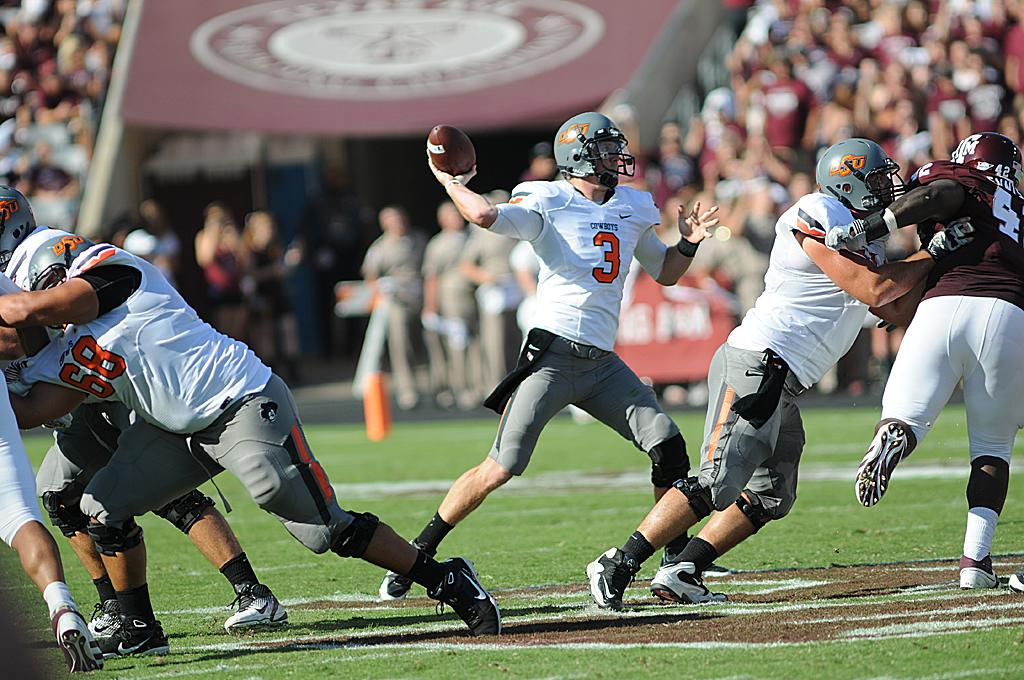What activity are the people in the image engaged in? The people in the image are playing a game. Where is the game being played? The game is being played on the grass. What object is being used in the game? A person is holding a ball in the image. Can you describe the background of the image? The background of the image is blurry. Are there any other people visible in the image besides the ones playing the game? Yes, there are people visible in the background of the image. What type of muscle is being exercised by the people playing the game in the image? There is no specific muscle being exercised by the people playing the game in the image. Can you see any bubbles in the image? There are no bubbles visible in the image. 